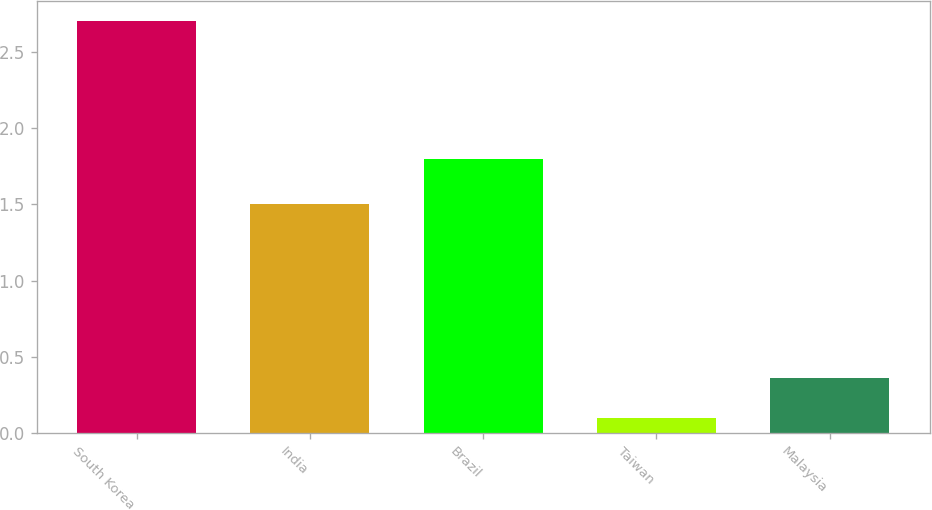Convert chart. <chart><loc_0><loc_0><loc_500><loc_500><bar_chart><fcel>South Korea<fcel>India<fcel>Brazil<fcel>Taiwan<fcel>Malaysia<nl><fcel>2.7<fcel>1.5<fcel>1.8<fcel>0.1<fcel>0.36<nl></chart> 